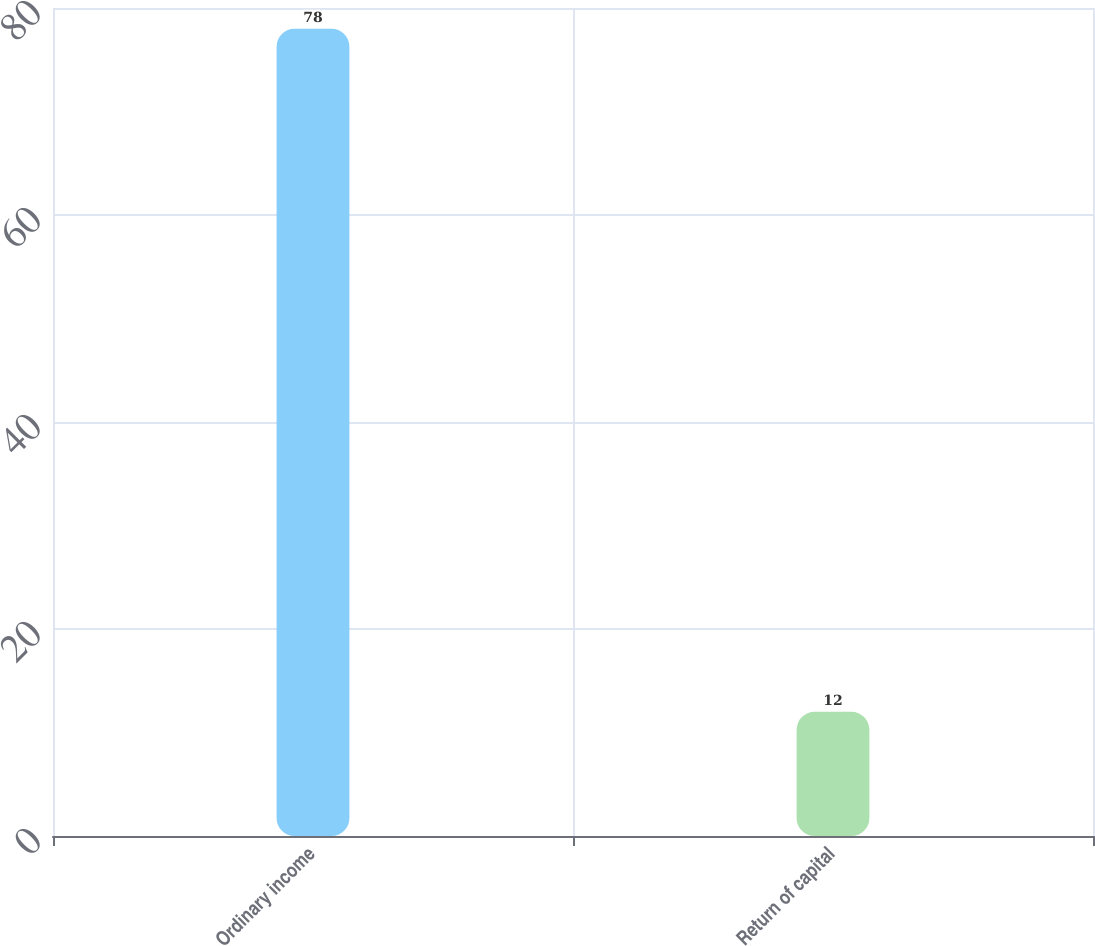<chart> <loc_0><loc_0><loc_500><loc_500><bar_chart><fcel>Ordinary income<fcel>Return of capital<nl><fcel>78<fcel>12<nl></chart> 